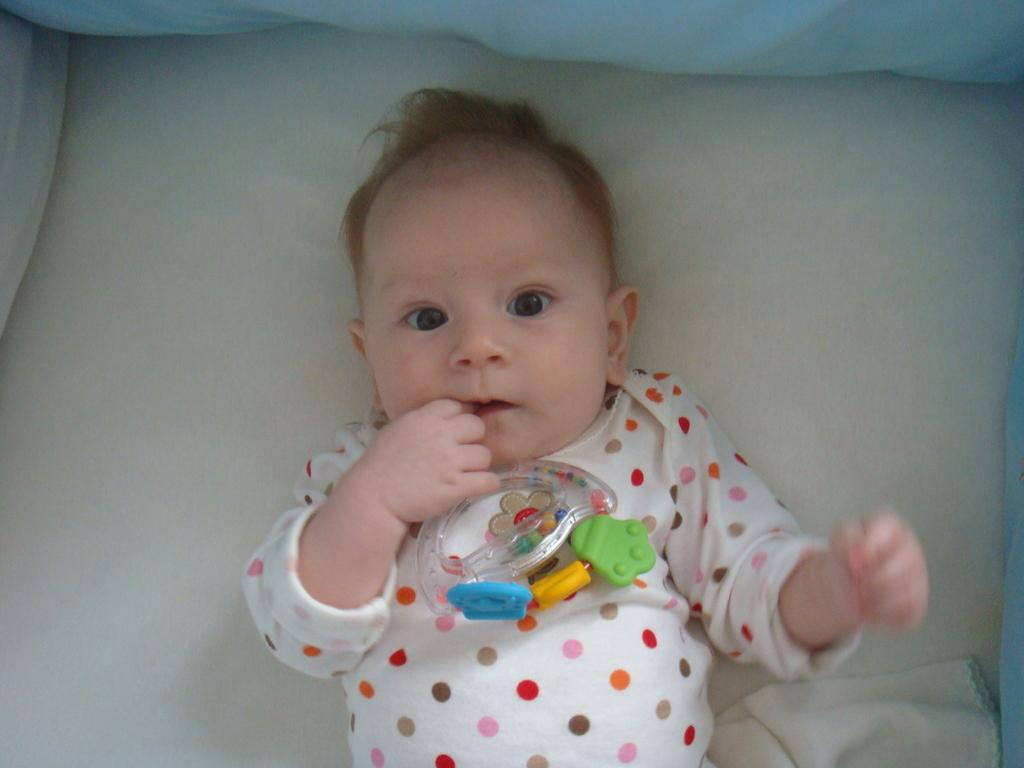What is the main subject of the image? There is a baby lying on a bed in the center of the image. What is located at the top of the image? There is a pillow at the top of the image. Where is the cloth positioned in the image? There is a cloth in the bottom right corner of the image. What type of attraction can be seen in the background of the image? There is no attraction visible in the image; it only features a baby lying on a bed, a pillow, and a cloth. 